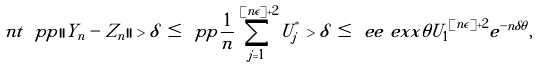<formula> <loc_0><loc_0><loc_500><loc_500>\ n t \ p p { | | Y _ { n } - Z _ { n } | | > \delta } \, & \leq \, \ p p { \frac { 1 } { n } \sum _ { j = 1 } ^ { [ n \epsilon ] + 2 } U _ { j } ^ { ^ { * } } > \delta } \, \leq \, \ e e { \ e x x { \theta U _ { 1 } } } ^ { [ n \epsilon ] + 2 } e ^ { - n \delta \theta } ,</formula> 